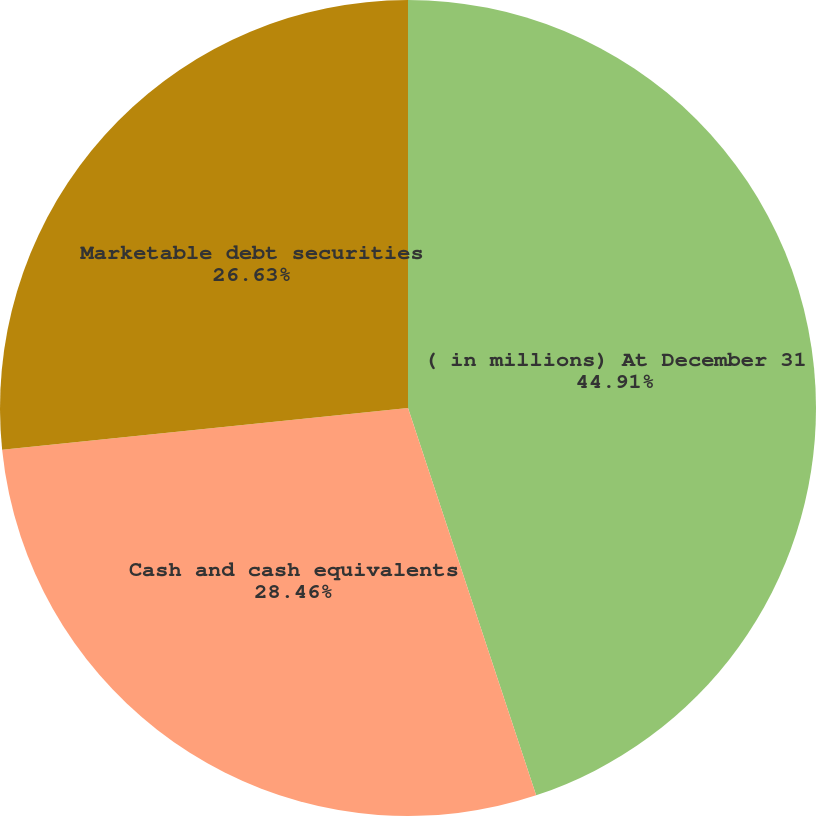<chart> <loc_0><loc_0><loc_500><loc_500><pie_chart><fcel>( in millions) At December 31<fcel>Cash and cash equivalents<fcel>Marketable debt securities<nl><fcel>44.92%<fcel>28.46%<fcel>26.63%<nl></chart> 